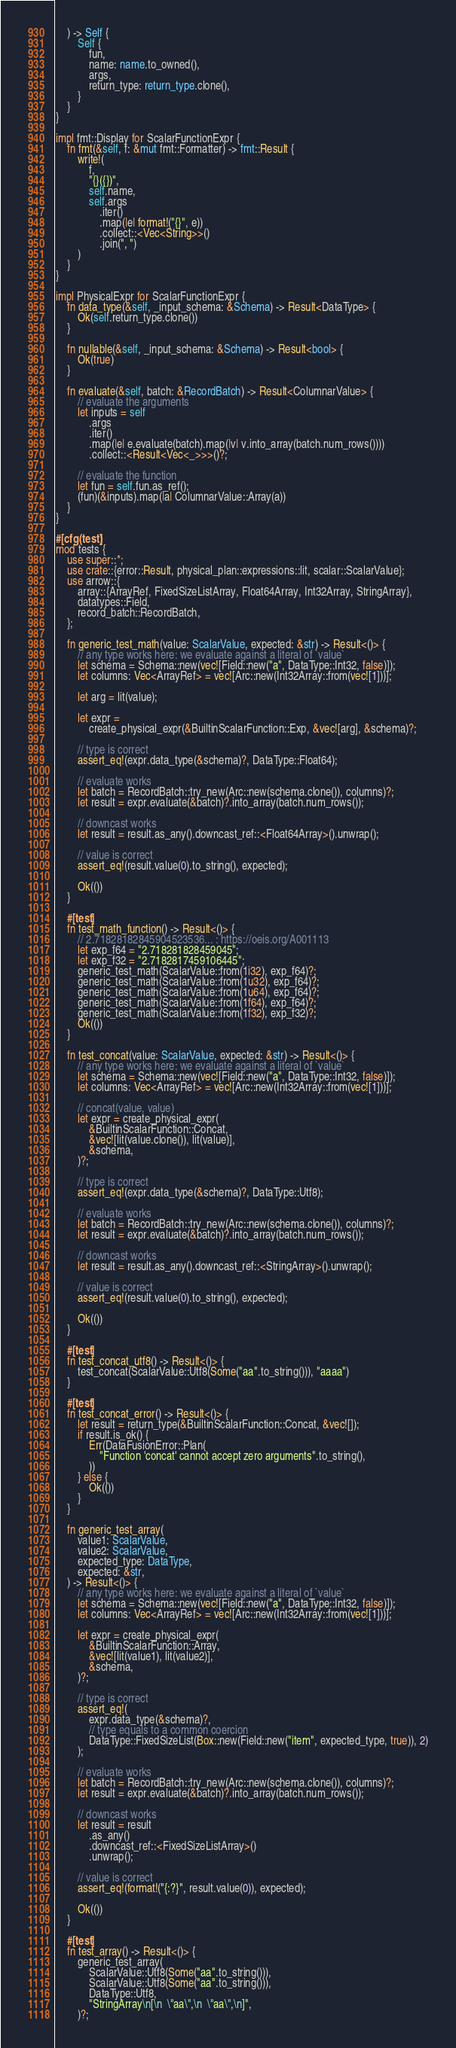Convert code to text. <code><loc_0><loc_0><loc_500><loc_500><_Rust_>    ) -> Self {
        Self {
            fun,
            name: name.to_owned(),
            args,
            return_type: return_type.clone(),
        }
    }
}

impl fmt::Display for ScalarFunctionExpr {
    fn fmt(&self, f: &mut fmt::Formatter) -> fmt::Result {
        write!(
            f,
            "{}({})",
            self.name,
            self.args
                .iter()
                .map(|e| format!("{}", e))
                .collect::<Vec<String>>()
                .join(", ")
        )
    }
}

impl PhysicalExpr for ScalarFunctionExpr {
    fn data_type(&self, _input_schema: &Schema) -> Result<DataType> {
        Ok(self.return_type.clone())
    }

    fn nullable(&self, _input_schema: &Schema) -> Result<bool> {
        Ok(true)
    }

    fn evaluate(&self, batch: &RecordBatch) -> Result<ColumnarValue> {
        // evaluate the arguments
        let inputs = self
            .args
            .iter()
            .map(|e| e.evaluate(batch).map(|v| v.into_array(batch.num_rows())))
            .collect::<Result<Vec<_>>>()?;

        // evaluate the function
        let fun = self.fun.as_ref();
        (fun)(&inputs).map(|a| ColumnarValue::Array(a))
    }
}

#[cfg(test)]
mod tests {
    use super::*;
    use crate::{error::Result, physical_plan::expressions::lit, scalar::ScalarValue};
    use arrow::{
        array::{ArrayRef, FixedSizeListArray, Float64Array, Int32Array, StringArray},
        datatypes::Field,
        record_batch::RecordBatch,
    };

    fn generic_test_math(value: ScalarValue, expected: &str) -> Result<()> {
        // any type works here: we evaluate against a literal of `value`
        let schema = Schema::new(vec![Field::new("a", DataType::Int32, false)]);
        let columns: Vec<ArrayRef> = vec![Arc::new(Int32Array::from(vec![1]))];

        let arg = lit(value);

        let expr =
            create_physical_expr(&BuiltinScalarFunction::Exp, &vec![arg], &schema)?;

        // type is correct
        assert_eq!(expr.data_type(&schema)?, DataType::Float64);

        // evaluate works
        let batch = RecordBatch::try_new(Arc::new(schema.clone()), columns)?;
        let result = expr.evaluate(&batch)?.into_array(batch.num_rows());

        // downcast works
        let result = result.as_any().downcast_ref::<Float64Array>().unwrap();

        // value is correct
        assert_eq!(result.value(0).to_string(), expected);

        Ok(())
    }

    #[test]
    fn test_math_function() -> Result<()> {
        // 2.71828182845904523536... : https://oeis.org/A001113
        let exp_f64 = "2.718281828459045";
        let exp_f32 = "2.7182817459106445";
        generic_test_math(ScalarValue::from(1i32), exp_f64)?;
        generic_test_math(ScalarValue::from(1u32), exp_f64)?;
        generic_test_math(ScalarValue::from(1u64), exp_f64)?;
        generic_test_math(ScalarValue::from(1f64), exp_f64)?;
        generic_test_math(ScalarValue::from(1f32), exp_f32)?;
        Ok(())
    }

    fn test_concat(value: ScalarValue, expected: &str) -> Result<()> {
        // any type works here: we evaluate against a literal of `value`
        let schema = Schema::new(vec![Field::new("a", DataType::Int32, false)]);
        let columns: Vec<ArrayRef> = vec![Arc::new(Int32Array::from(vec![1]))];

        // concat(value, value)
        let expr = create_physical_expr(
            &BuiltinScalarFunction::Concat,
            &vec![lit(value.clone()), lit(value)],
            &schema,
        )?;

        // type is correct
        assert_eq!(expr.data_type(&schema)?, DataType::Utf8);

        // evaluate works
        let batch = RecordBatch::try_new(Arc::new(schema.clone()), columns)?;
        let result = expr.evaluate(&batch)?.into_array(batch.num_rows());

        // downcast works
        let result = result.as_any().downcast_ref::<StringArray>().unwrap();

        // value is correct
        assert_eq!(result.value(0).to_string(), expected);

        Ok(())
    }

    #[test]
    fn test_concat_utf8() -> Result<()> {
        test_concat(ScalarValue::Utf8(Some("aa".to_string())), "aaaa")
    }

    #[test]
    fn test_concat_error() -> Result<()> {
        let result = return_type(&BuiltinScalarFunction::Concat, &vec![]);
        if result.is_ok() {
            Err(DataFusionError::Plan(
                "Function 'concat' cannot accept zero arguments".to_string(),
            ))
        } else {
            Ok(())
        }
    }

    fn generic_test_array(
        value1: ScalarValue,
        value2: ScalarValue,
        expected_type: DataType,
        expected: &str,
    ) -> Result<()> {
        // any type works here: we evaluate against a literal of `value`
        let schema = Schema::new(vec![Field::new("a", DataType::Int32, false)]);
        let columns: Vec<ArrayRef> = vec![Arc::new(Int32Array::from(vec![1]))];

        let expr = create_physical_expr(
            &BuiltinScalarFunction::Array,
            &vec![lit(value1), lit(value2)],
            &schema,
        )?;

        // type is correct
        assert_eq!(
            expr.data_type(&schema)?,
            // type equals to a common coercion
            DataType::FixedSizeList(Box::new(Field::new("item", expected_type, true)), 2)
        );

        // evaluate works
        let batch = RecordBatch::try_new(Arc::new(schema.clone()), columns)?;
        let result = expr.evaluate(&batch)?.into_array(batch.num_rows());

        // downcast works
        let result = result
            .as_any()
            .downcast_ref::<FixedSizeListArray>()
            .unwrap();

        // value is correct
        assert_eq!(format!("{:?}", result.value(0)), expected);

        Ok(())
    }

    #[test]
    fn test_array() -> Result<()> {
        generic_test_array(
            ScalarValue::Utf8(Some("aa".to_string())),
            ScalarValue::Utf8(Some("aa".to_string())),
            DataType::Utf8,
            "StringArray\n[\n  \"aa\",\n  \"aa\",\n]",
        )?;
</code> 